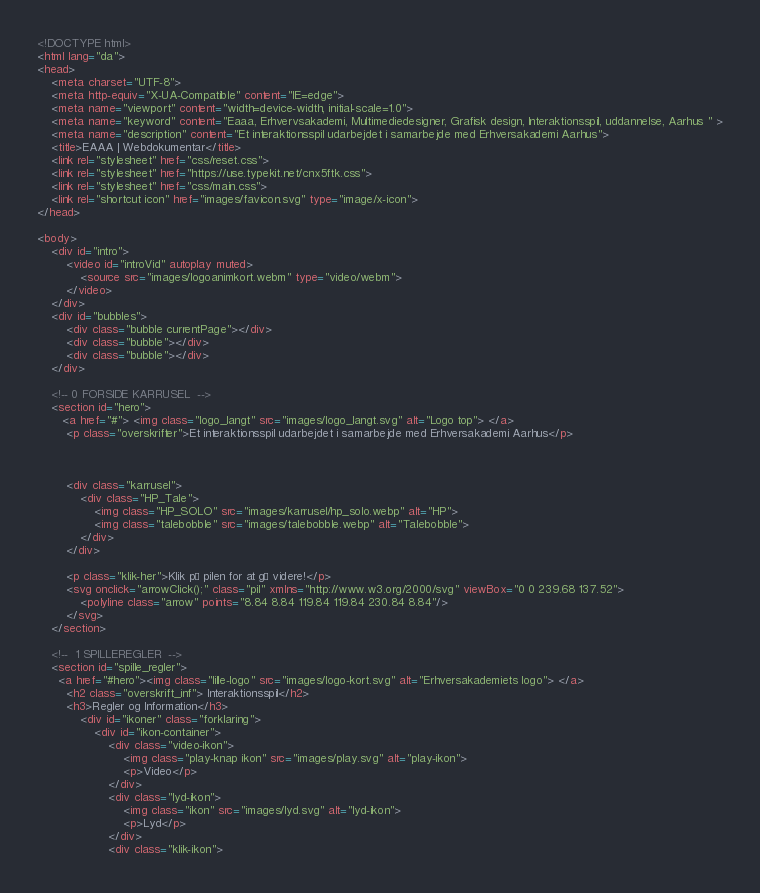Convert code to text. <code><loc_0><loc_0><loc_500><loc_500><_HTML_><!DOCTYPE html>
<html lang="da">
<head>
    <meta charset="UTF-8">
    <meta http-equiv="X-UA-Compatible" content="IE=edge">
    <meta name="viewport" content="width=device-width, initial-scale=1.0">
    <meta name="keyword" content="Eaaa, Erhvervsakademi, Multimediedesigner, Grafisk design, Interaktionsspil, uddannelse, Aarhus " >
    <meta name="description" content="Et interaktionsspil udarbejdet i samarbejde med Erhversakademi Aarhus">
    <title>EAAA | Webdokumentar</title>
    <link rel="stylesheet" href="css/reset.css">
    <link rel="stylesheet" href="https://use.typekit.net/cnx5ftk.css">
    <link rel="stylesheet" href="css/main.css">
    <link rel="shortcut icon" href="images/favicon.svg" type="image/x-icon">
</head>

<body>
    <div id="intro">
        <video id="introVid" autoplay muted>
            <source src="images/logoanimkort.webm" type="video/webm">
        </video>
    </div>
    <div id="bubbles">
        <div class="bubble currentPage"></div>
        <div class="bubble"></div>
        <div class="bubble"></div>
    </div>

    <!-- 0 FORSIDE KARRUSEL  -->
    <section id="hero">
       <a href="#"> <img class="logo_langt" src="images/logo_langt.svg" alt="Logo top"> </a>
        <p class="overskrifter">Et interaktionsspil udarbejdet i samarbejde med Erhversakademi Aarhus</p>
        


        <div class="karrusel">
            <div class="HP_Tale">
                <img class="HP_SOLO" src="images/karrusel/hp_solo.webp" alt="HP">
                <img class="talebobble" src="images/talebobble.webp" alt="Talebobble">
            </div>
        </div>

        <p class="klik-her">Klik på pilen for at gå videre!</p>
        <svg onclick="arrowClick();" class="pil" xmlns="http://www.w3.org/2000/svg" viewBox="0 0 239.68 137.52">
            <polyline class="arrow" points="8.84 8.84 119.84 119.84 230.84 8.84"/>
        </svg>
    </section>

    <!--  1 SPILLEREGLER  -->
    <section id="spille_regler">
      <a href="#hero"><img class="lille-logo" src="images/logo-kort.svg" alt="Erhversakademiets logo"> </a>
        <h2 class="overskrift_inf"> Interaktionsspil</h2>
        <h3>Regler og Information</h3>
            <div id="ikoner" class="forklaring">
                <div id="ikon-container">
                    <div class="video-ikon">
                        <img class="play-knap ikon" src="images/play.svg" alt="play-ikon">
                        <p>Video</p>
                    </div>
                    <div class="lyd-ikon">
                        <img class="ikon" src="images/lyd.svg" alt="lyd-ikon">
                        <p>Lyd</p>
                    </div>
                    <div class="klik-ikon"></code> 